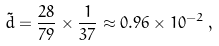Convert formula to latex. <formula><loc_0><loc_0><loc_500><loc_500>\tilde { d } = \frac { 2 8 } { 7 9 } \times \frac { 1 } { 3 7 } \approx 0 . 9 6 \times 1 0 ^ { - 2 } \, ,</formula> 